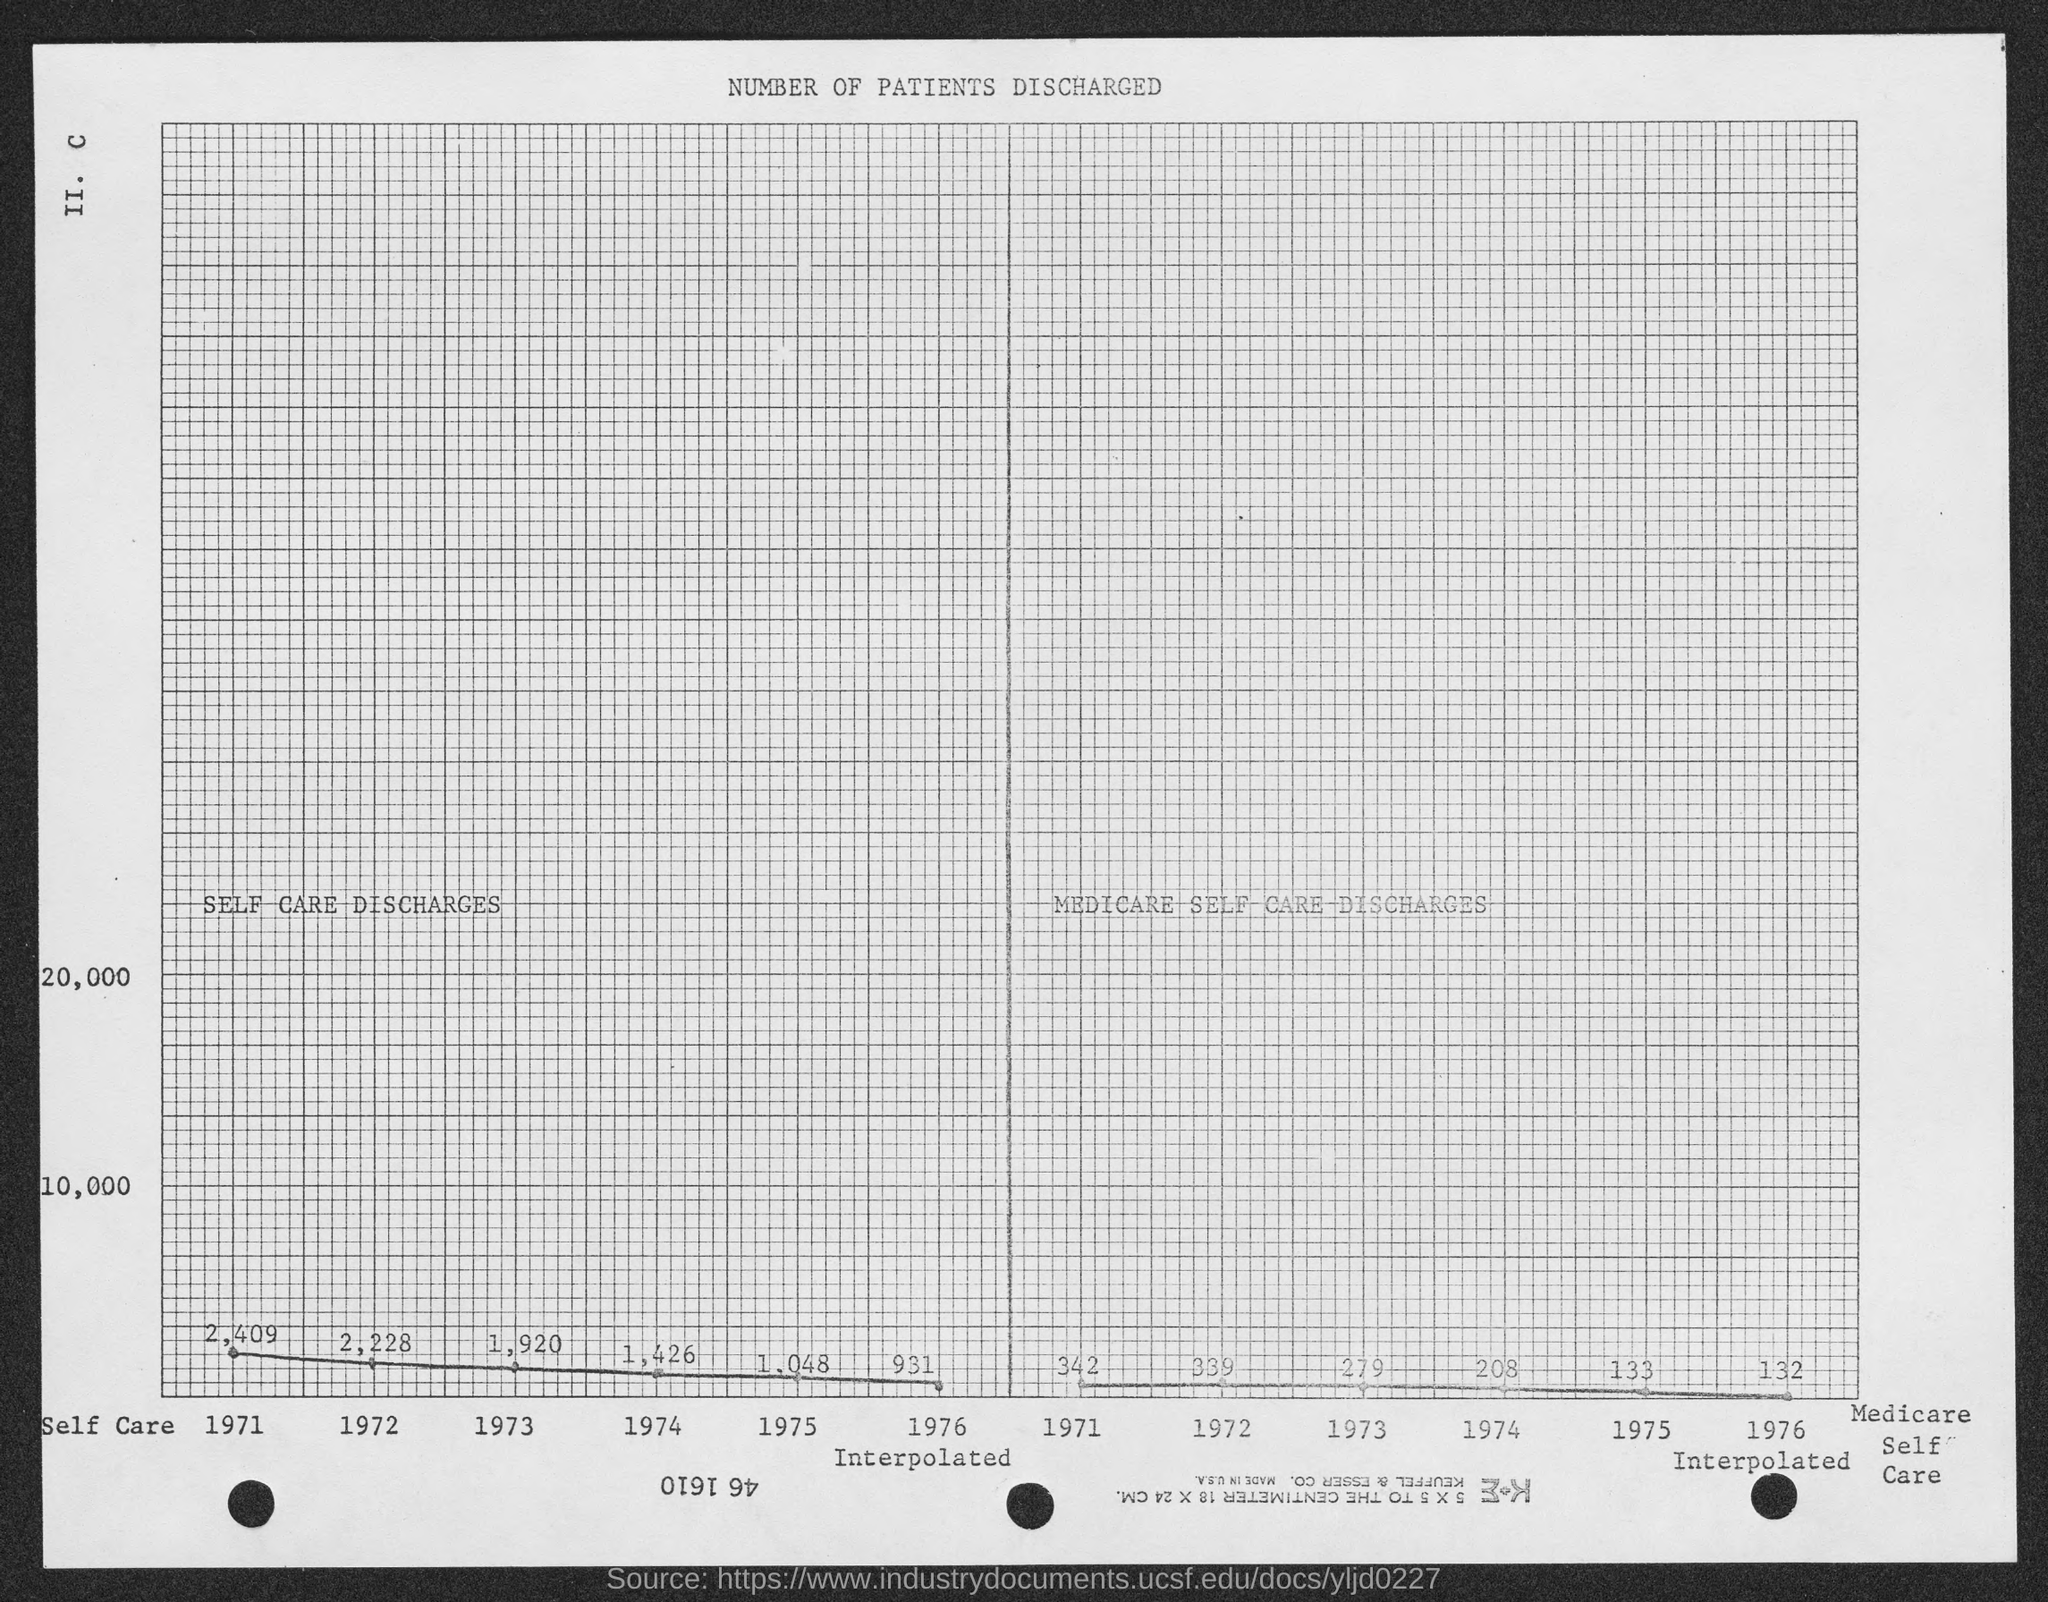Draw attention to some important aspects in this diagram. The top of the page indicates that the number of patients discharged has been recorded. 